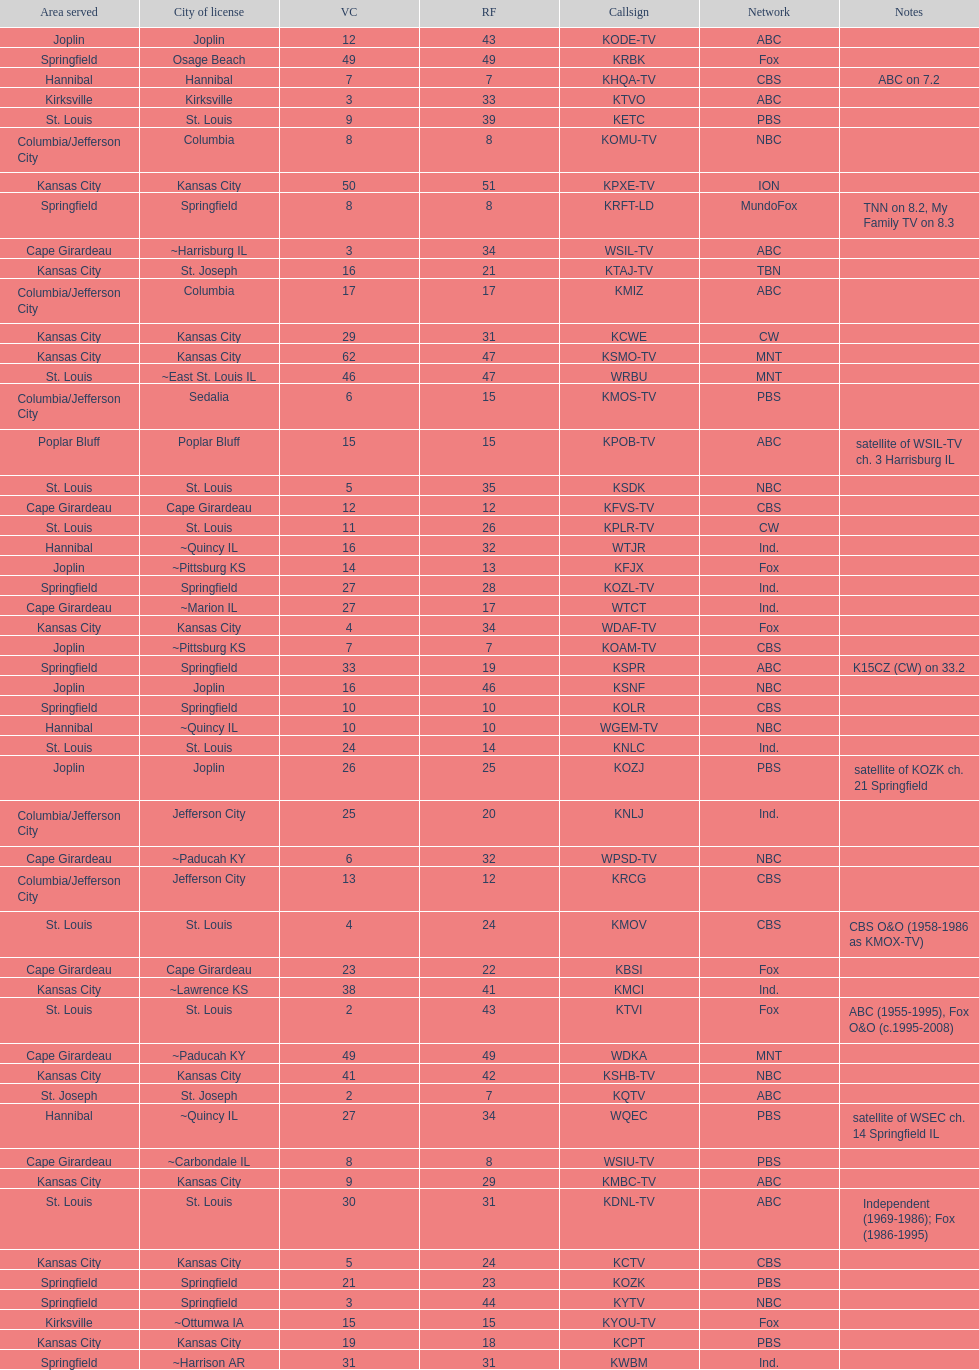How many are on the cbs network? 7. 